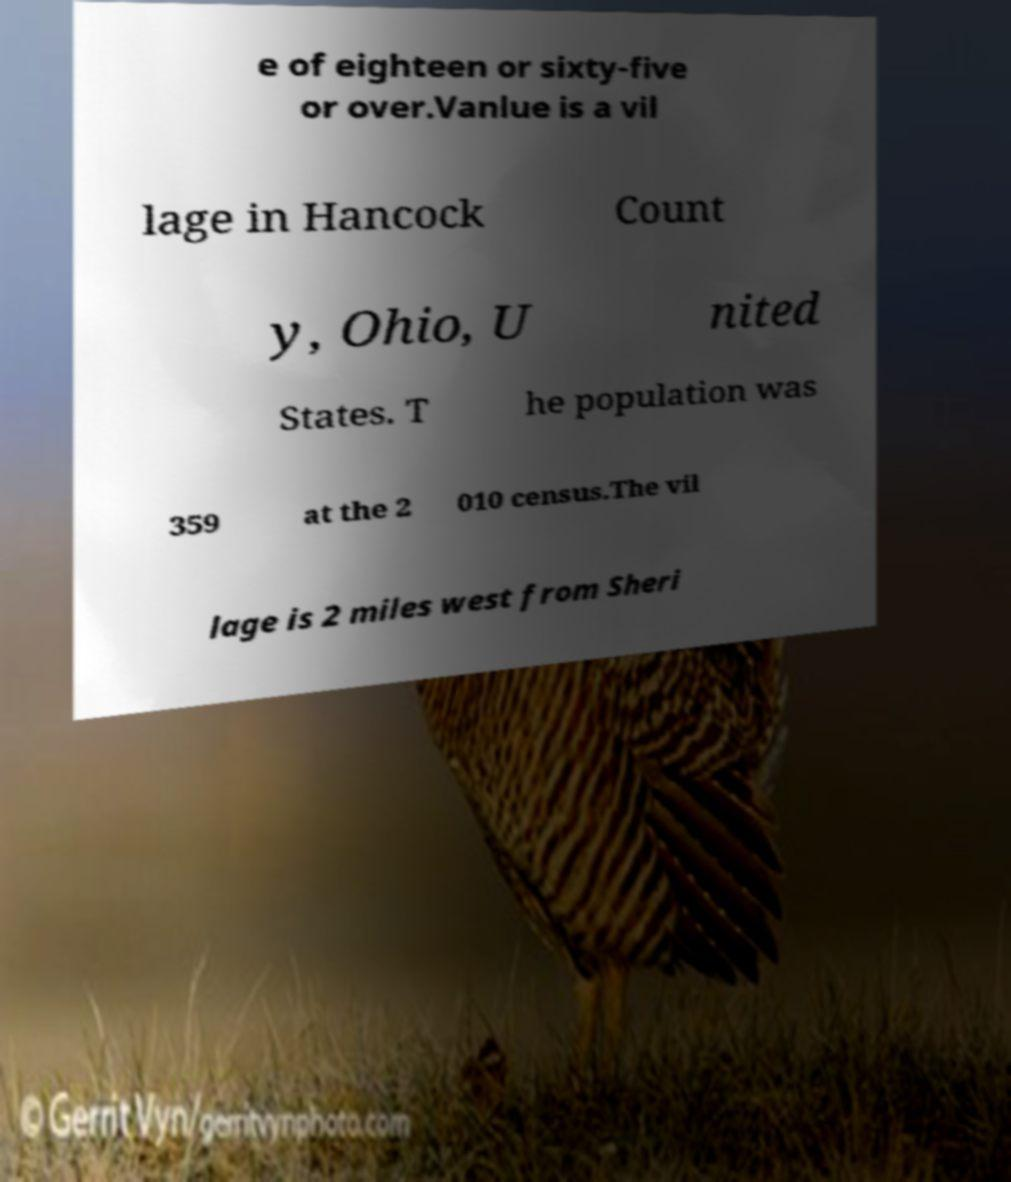Please read and relay the text visible in this image. What does it say? e of eighteen or sixty-five or over.Vanlue is a vil lage in Hancock Count y, Ohio, U nited States. T he population was 359 at the 2 010 census.The vil lage is 2 miles west from Sheri 